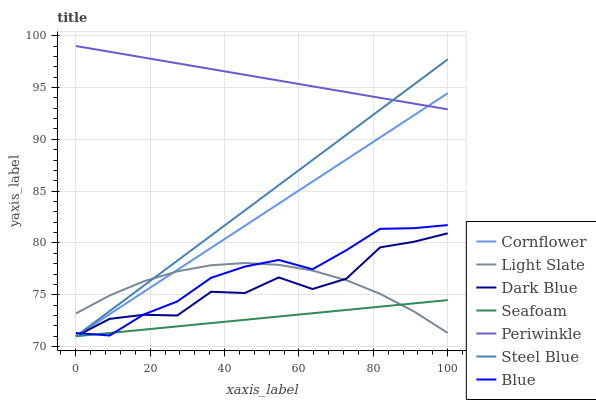Does Seafoam have the minimum area under the curve?
Answer yes or no. Yes. Does Periwinkle have the maximum area under the curve?
Answer yes or no. Yes. Does Cornflower have the minimum area under the curve?
Answer yes or no. No. Does Cornflower have the maximum area under the curve?
Answer yes or no. No. Is Cornflower the smoothest?
Answer yes or no. Yes. Is Dark Blue the roughest?
Answer yes or no. Yes. Is Light Slate the smoothest?
Answer yes or no. No. Is Light Slate the roughest?
Answer yes or no. No. Does Cornflower have the lowest value?
Answer yes or no. Yes. Does Light Slate have the lowest value?
Answer yes or no. No. Does Periwinkle have the highest value?
Answer yes or no. Yes. Does Cornflower have the highest value?
Answer yes or no. No. Is Light Slate less than Periwinkle?
Answer yes or no. Yes. Is Periwinkle greater than Blue?
Answer yes or no. Yes. Does Light Slate intersect Seafoam?
Answer yes or no. Yes. Is Light Slate less than Seafoam?
Answer yes or no. No. Is Light Slate greater than Seafoam?
Answer yes or no. No. Does Light Slate intersect Periwinkle?
Answer yes or no. No. 